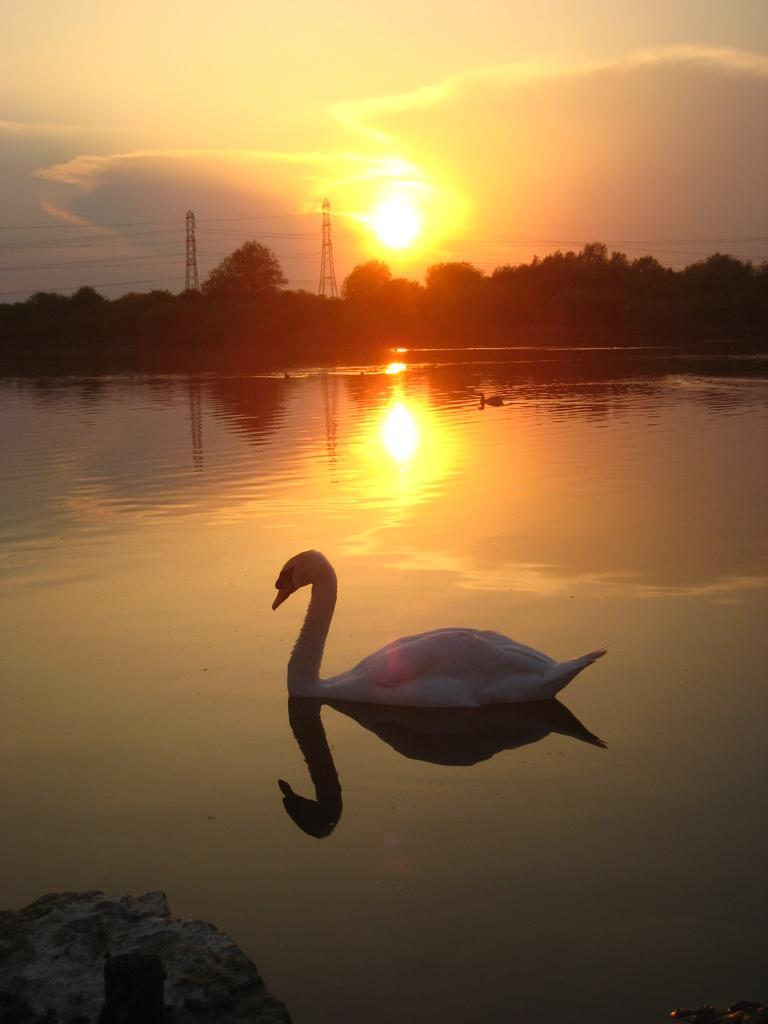What is the main subject of the image? The main subject of the image is a water surface. What is floating on the water surface? There are two swans floating on the water surface. What can be seen in the background of the image? There are trees and towers in the background of the image. What type of plants can be seen growing on the swans in the image? There are no plants growing on the swans in the image; they are simply floating on the water surface. What type of fork is being used by the swans to navigate the water in the image? There is no fork present in the image, and swans do not use forks to navigate water. 